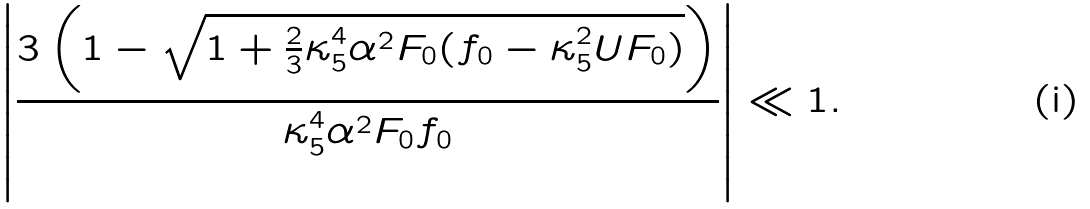<formula> <loc_0><loc_0><loc_500><loc_500>\left | \frac { 3 \left ( 1 - \sqrt { 1 + \frac { 2 } { 3 } \kappa _ { 5 } ^ { 4 } \alpha ^ { 2 } F _ { 0 } ( f _ { 0 } - \kappa _ { 5 } ^ { 2 } U F _ { 0 } ) } \right ) } { \kappa _ { 5 } ^ { 4 } \alpha ^ { 2 } F _ { 0 } f _ { 0 } } \right | \ll 1 .</formula> 